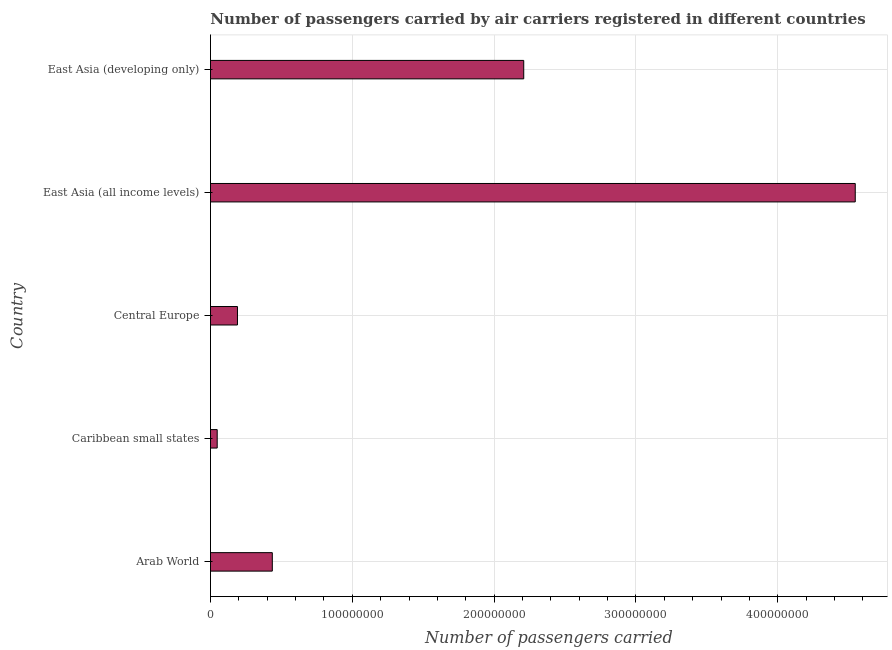What is the title of the graph?
Your response must be concise. Number of passengers carried by air carriers registered in different countries. What is the label or title of the X-axis?
Give a very brief answer. Number of passengers carried. What is the label or title of the Y-axis?
Ensure brevity in your answer.  Country. What is the number of passengers carried in East Asia (developing only)?
Offer a terse response. 2.21e+08. Across all countries, what is the maximum number of passengers carried?
Offer a terse response. 4.55e+08. Across all countries, what is the minimum number of passengers carried?
Ensure brevity in your answer.  4.74e+06. In which country was the number of passengers carried maximum?
Offer a terse response. East Asia (all income levels). In which country was the number of passengers carried minimum?
Your response must be concise. Caribbean small states. What is the sum of the number of passengers carried?
Your answer should be very brief. 7.43e+08. What is the difference between the number of passengers carried in Caribbean small states and Central Europe?
Provide a short and direct response. -1.43e+07. What is the average number of passengers carried per country?
Offer a very short reply. 1.49e+08. What is the median number of passengers carried?
Keep it short and to the point. 4.36e+07. In how many countries, is the number of passengers carried greater than 380000000 ?
Ensure brevity in your answer.  1. What is the ratio of the number of passengers carried in Caribbean small states to that in Central Europe?
Offer a terse response. 0.25. What is the difference between the highest and the second highest number of passengers carried?
Your answer should be compact. 2.34e+08. What is the difference between the highest and the lowest number of passengers carried?
Your response must be concise. 4.50e+08. Are all the bars in the graph horizontal?
Offer a terse response. Yes. How many countries are there in the graph?
Offer a very short reply. 5. What is the Number of passengers carried in Arab World?
Keep it short and to the point. 4.36e+07. What is the Number of passengers carried of Caribbean small states?
Offer a terse response. 4.74e+06. What is the Number of passengers carried of Central Europe?
Your answer should be very brief. 1.90e+07. What is the Number of passengers carried of East Asia (all income levels)?
Offer a very short reply. 4.55e+08. What is the Number of passengers carried in East Asia (developing only)?
Provide a short and direct response. 2.21e+08. What is the difference between the Number of passengers carried in Arab World and Caribbean small states?
Ensure brevity in your answer.  3.89e+07. What is the difference between the Number of passengers carried in Arab World and Central Europe?
Your answer should be very brief. 2.46e+07. What is the difference between the Number of passengers carried in Arab World and East Asia (all income levels)?
Provide a short and direct response. -4.11e+08. What is the difference between the Number of passengers carried in Arab World and East Asia (developing only)?
Provide a short and direct response. -1.77e+08. What is the difference between the Number of passengers carried in Caribbean small states and Central Europe?
Make the answer very short. -1.43e+07. What is the difference between the Number of passengers carried in Caribbean small states and East Asia (all income levels)?
Provide a short and direct response. -4.50e+08. What is the difference between the Number of passengers carried in Caribbean small states and East Asia (developing only)?
Provide a short and direct response. -2.16e+08. What is the difference between the Number of passengers carried in Central Europe and East Asia (all income levels)?
Your response must be concise. -4.36e+08. What is the difference between the Number of passengers carried in Central Europe and East Asia (developing only)?
Your answer should be very brief. -2.02e+08. What is the difference between the Number of passengers carried in East Asia (all income levels) and East Asia (developing only)?
Provide a short and direct response. 2.34e+08. What is the ratio of the Number of passengers carried in Arab World to that in Caribbean small states?
Offer a very short reply. 9.2. What is the ratio of the Number of passengers carried in Arab World to that in Central Europe?
Your answer should be compact. 2.29. What is the ratio of the Number of passengers carried in Arab World to that in East Asia (all income levels)?
Offer a terse response. 0.1. What is the ratio of the Number of passengers carried in Arab World to that in East Asia (developing only)?
Offer a very short reply. 0.2. What is the ratio of the Number of passengers carried in Caribbean small states to that in Central Europe?
Your answer should be compact. 0.25. What is the ratio of the Number of passengers carried in Caribbean small states to that in East Asia (all income levels)?
Your answer should be very brief. 0.01. What is the ratio of the Number of passengers carried in Caribbean small states to that in East Asia (developing only)?
Make the answer very short. 0.02. What is the ratio of the Number of passengers carried in Central Europe to that in East Asia (all income levels)?
Your answer should be very brief. 0.04. What is the ratio of the Number of passengers carried in Central Europe to that in East Asia (developing only)?
Ensure brevity in your answer.  0.09. What is the ratio of the Number of passengers carried in East Asia (all income levels) to that in East Asia (developing only)?
Provide a short and direct response. 2.06. 